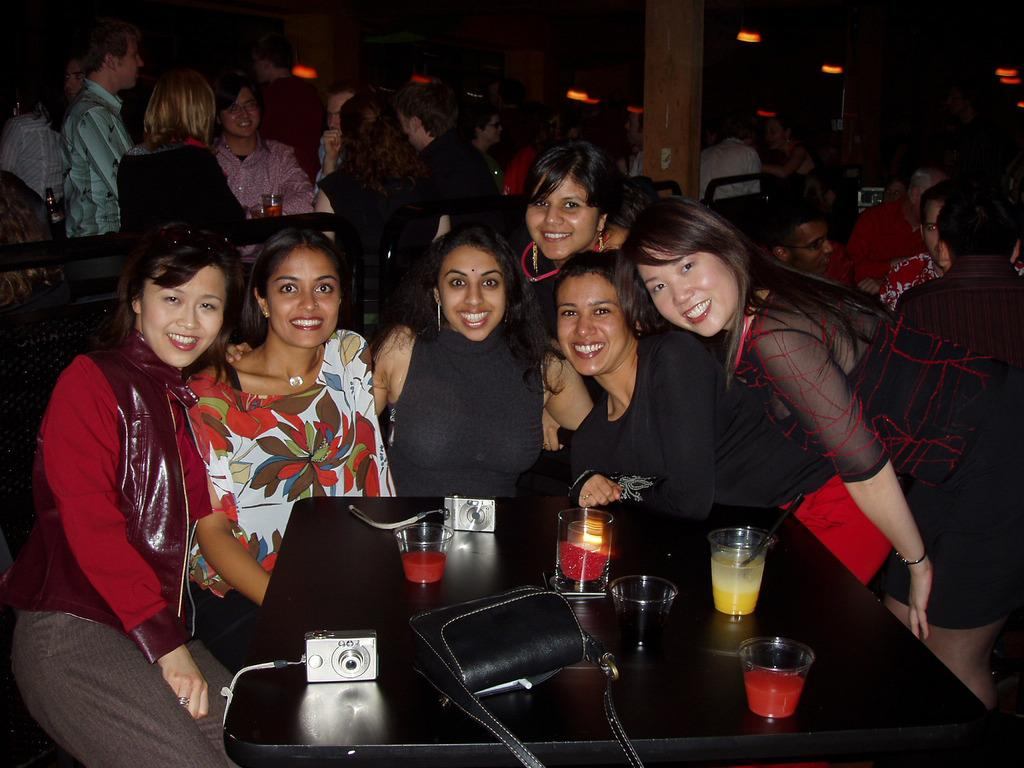What can be seen in the image? There is a group of women in the image. What objects are on the table? There are glasses, a camera, and a bag on the table. What else is visible in the background? There is a group of people and a pillar in the background. What type of toys are being played with by the women in the image? There are no toys present in the image; it features a group of women and various objects on a table. 